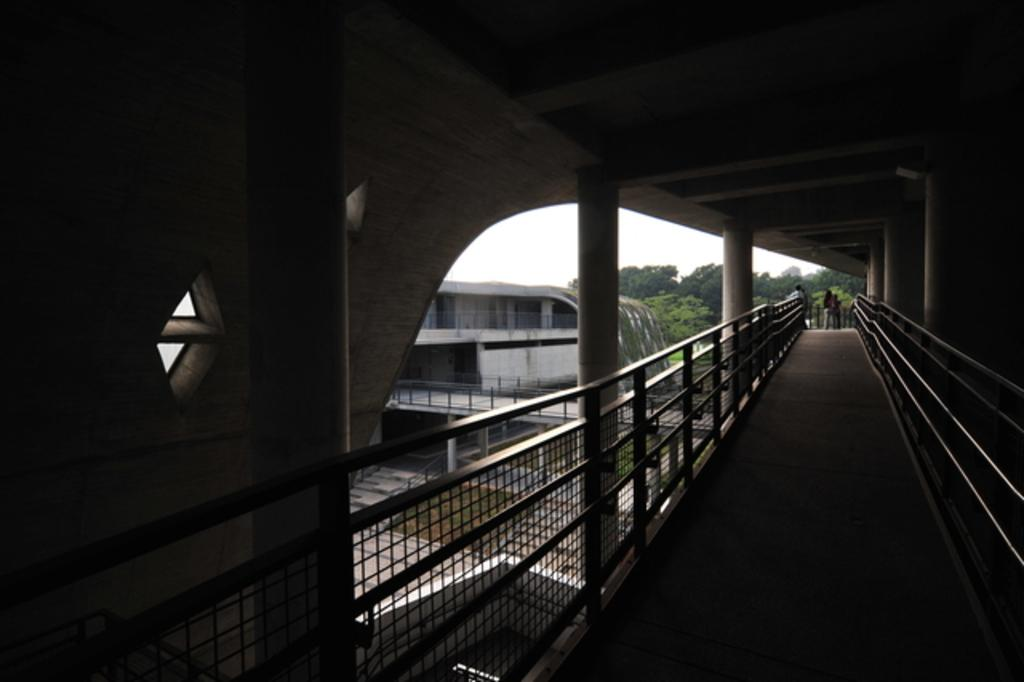What type of structure can be seen in the image? There is a fence, pillars, and a wall visible in the image. What can be seen in the background of the image? There is a building, trees, and the sky visible in the background of the image. Are there any people present in the image? Yes, there are people in the background of the image. What type of screw is being used to hold the wrench in the image? There is no screw or wrench present in the image. What scent can be detected from the image? The image does not convey any scents, as it is a visual representation. 